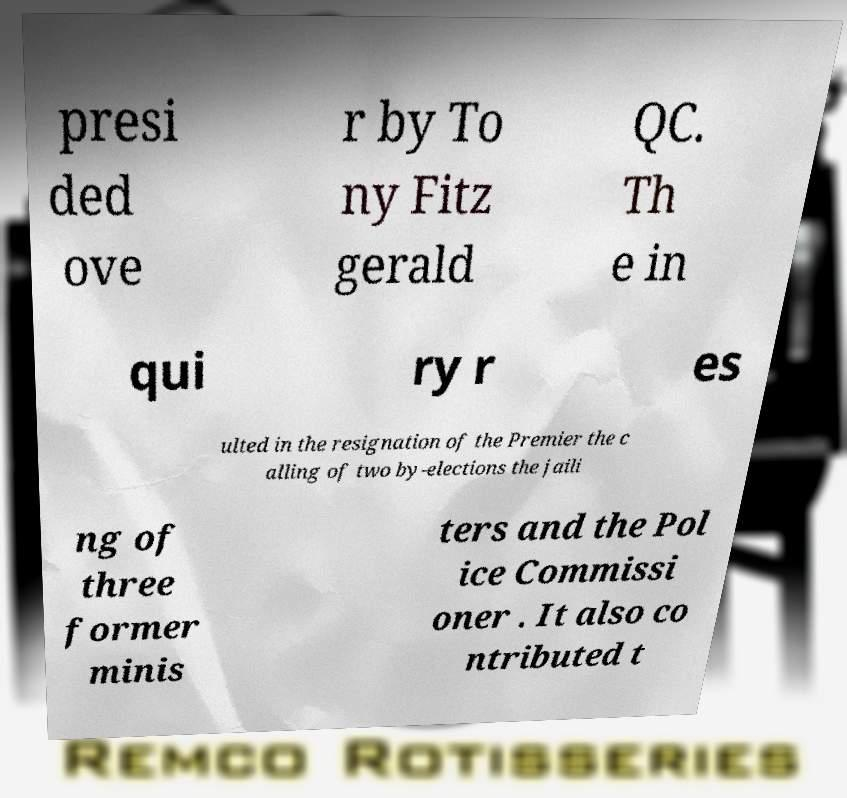What messages or text are displayed in this image? I need them in a readable, typed format. presi ded ove r by To ny Fitz gerald QC. Th e in qui ry r es ulted in the resignation of the Premier the c alling of two by-elections the jaili ng of three former minis ters and the Pol ice Commissi oner . It also co ntributed t 